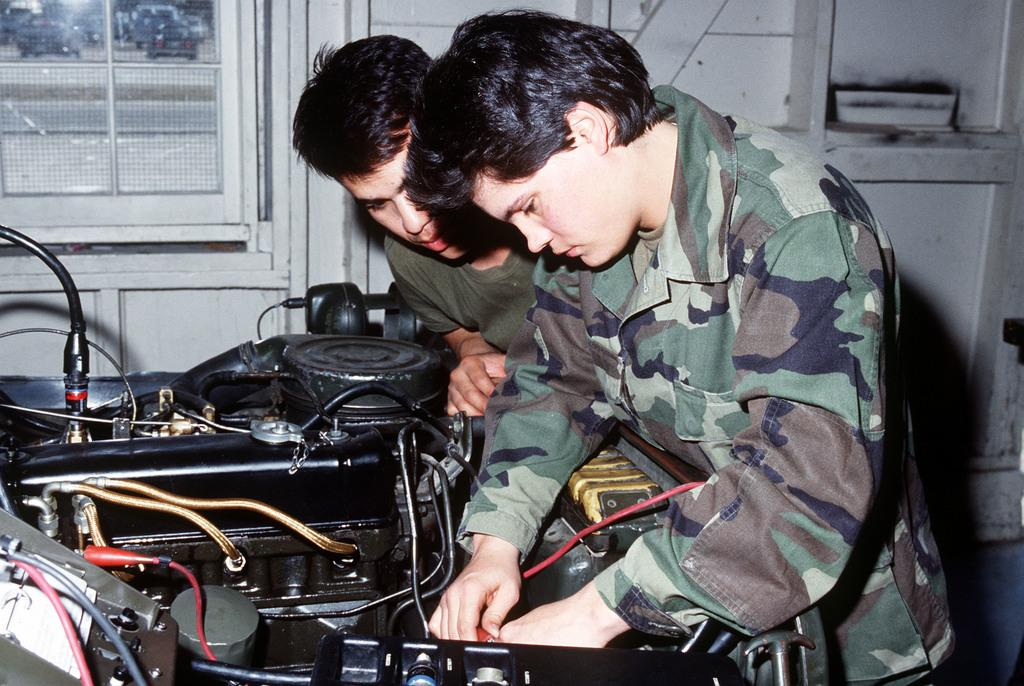How many people are present in the image? There are two persons standing in the image. What can be seen in the image besides the people? There is an electric machine, wires, a window, and a wall in the image. What type of land can be seen through the window in the image? There is no land visible through the window in the image, as it is an indoor setting. 